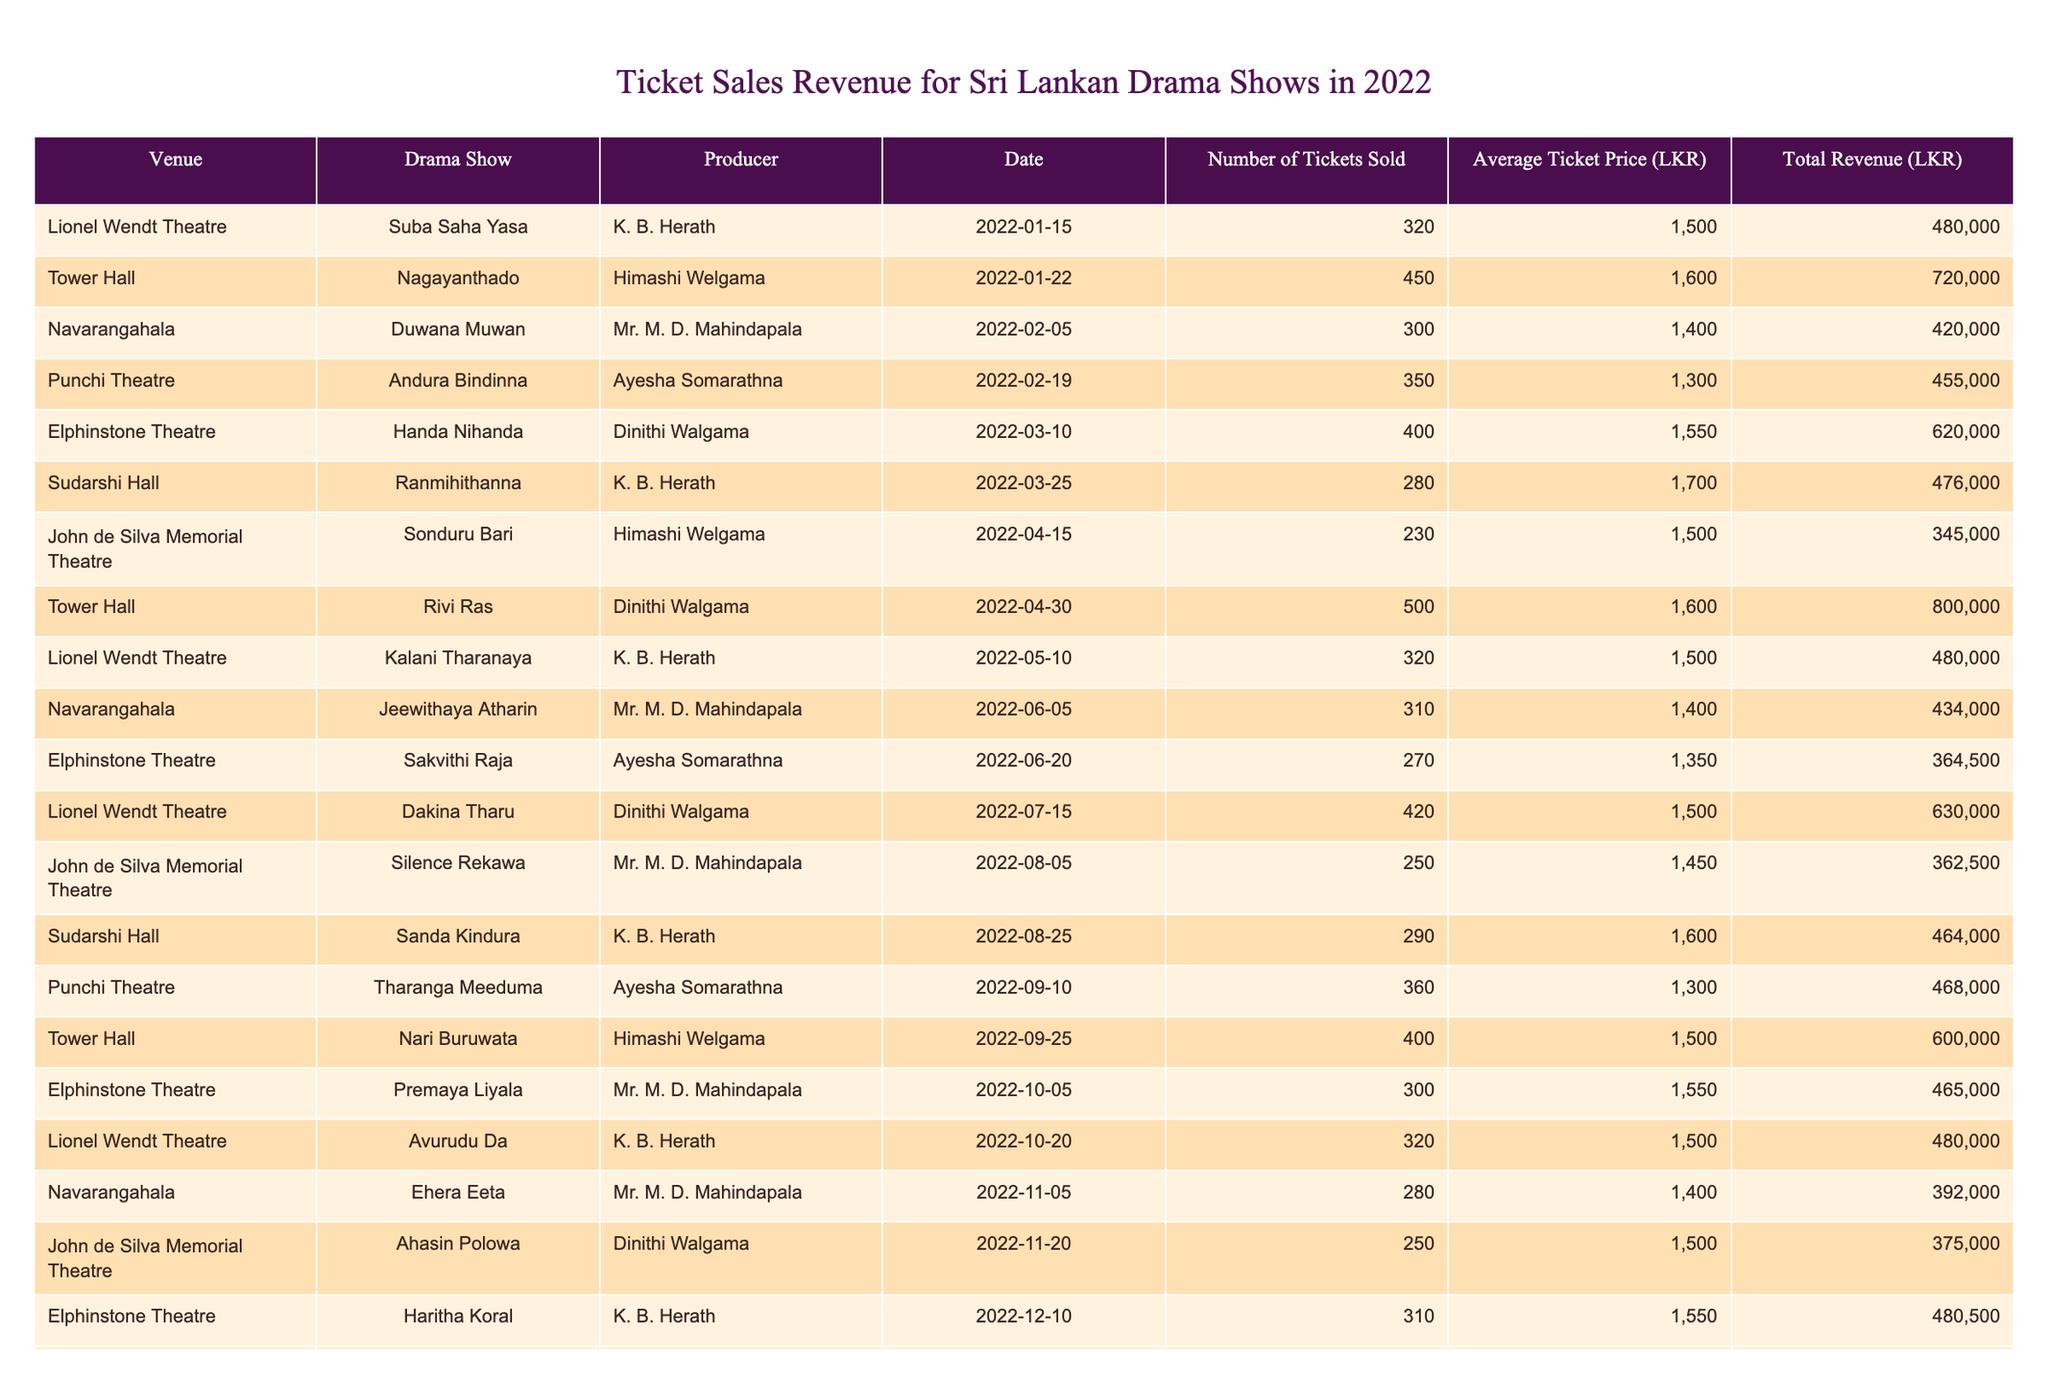What is the total revenue earned from the show "Suba Saha Yasa"? The total revenue for the show "Suba Saha Yasa" is listed under the Total Revenue column, which shows a value of 480000 LKR for the date 2022-01-15.
Answer: 480000 LKR How many tickets were sold for the show "Duwana Muwan"? The number of tickets sold for the show "Duwana Muwan" is found in the Number of Tickets Sold column, which indicates 300 tickets were sold on 2022-02-05.
Answer: 300 Which drama show had the highest total revenue, and what was that amount? By looking through the Total Revenue column, "Rivi Ras" under Tower Hall on 2022-04-30 has the highest figure of 800000 LKR.
Answer: Rivi Ras, 800000 LKR Was the average ticket price for "Andura Bindinna" higher than 1200 LKR? The average ticket price for "Andura Bindinna" listed in the Average Ticket Price column is 1300 LKR, which confirms that it is indeed higher than 1200 LKR.
Answer: Yes What is the combined total revenue of all shows produced by K. B. Herath? To determine this, we need to identify all the shows by K. B. Herath and then sum their revenues. The shows are "Suba Saha Yasa" (480000 LKR), "Suda Hansi" (480000 LKR), "Kalani Tharanaya" (480000 LKR), "Sanda Kindura" (464000 LKR), and "Haritha Koral" (480500 LKR). Adding these amounts gives: 480000 + 480000 + 480000 + 464000 + 480500 = 2380500 LKR.
Answer: 2380500 LKR How many total tickets were sold across all drama shows in March 2022? First, we look for all shows in March from the Date column. The shows are "Handa Nihanda" (400 tickets), "Ranmihithanna" (280 tickets) both recorded in March. Adding these gives: 400 + 280 = 680 tickets total sold in March 2022.
Answer: 680 Did "Rivi Ras" sell more tickets than "Ehera Eeta"? "Rivi Ras" sold 500 tickets on 2022-04-30, while "Ehera Eeta" sold 280 tickets on 2022-11-05. Since 500 is greater than 280, we conclude that "Rivi Ras" sold more tickets.
Answer: Yes What is the average ticket price for shows produced by Mr. M. D. Mahindapala? The shows produced by Mr. M. D. Mahindapala are "Duwana Muwan" (1400 LKR), "Jeewithaya Atharin" (1400 LKR), "Silence Rekawa" (1450 LKR), and "Premaya Liyala" (1550 LKR). To find the average, we calculate (1400 + 1400 + 1450 + 1550) / 4 = 1450 LKR.
Answer: 1450 LKR Which venue had the most shows in 2022? Analyzing the Venue column shows that Lionel Wendt Theatre had the most entries, with a total of 5 shows listed.
Answer: Lionel Wendt Theatre 